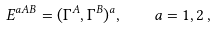Convert formula to latex. <formula><loc_0><loc_0><loc_500><loc_500>E ^ { a A B } = ( \Gamma ^ { A } , \Gamma ^ { B } ) ^ { a } , \quad a = 1 , 2 \, ,</formula> 